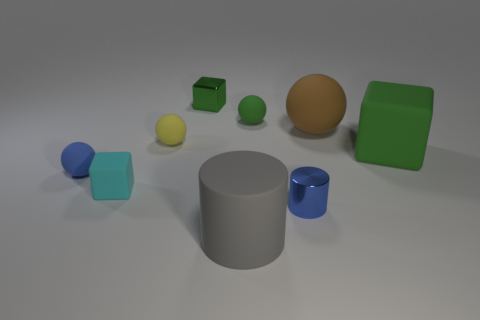Subtract all yellow rubber balls. How many balls are left? 3 Add 1 big gray cylinders. How many objects exist? 10 Subtract 1 blocks. How many blocks are left? 2 Subtract all blue cylinders. How many cylinders are left? 1 Subtract all cylinders. How many objects are left? 7 Subtract all cyan objects. Subtract all big brown matte spheres. How many objects are left? 7 Add 5 small green spheres. How many small green spheres are left? 6 Add 5 small balls. How many small balls exist? 8 Subtract 0 green cylinders. How many objects are left? 9 Subtract all purple cylinders. Subtract all green blocks. How many cylinders are left? 2 